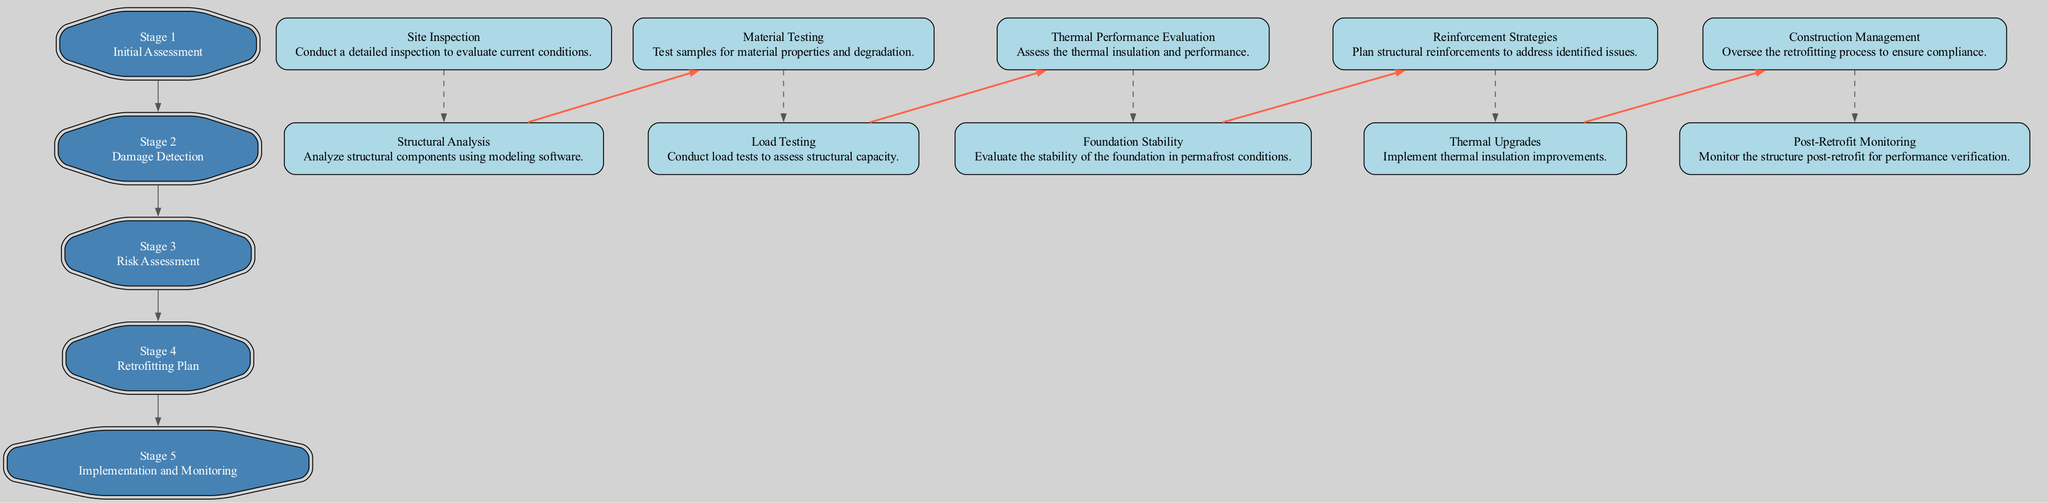What is the first stage in the clinical pathway? The first stage listed in the diagram is "Initial Assessment." By reviewing the stages from top to bottom, "Initial Assessment" is identified as the first stage.
Answer: Initial Assessment How many elements are in the "Risk Assessment" stage? In the "Risk Assessment" stage, there are two elements: "Thermal Performance Evaluation" and "Foundation Stability." Counting the elements in this stage confirms there are two.
Answer: 2 Which tools are used for "Material Testing"? The tools listed for "Material Testing" are: "Universal Testing Machine," "Spectrometer," and "Ultrasonic Tester." These three tools are specified under the "Material Testing" element in the "Damage Detection" stage.
Answer: Universal Testing Machine, Spectrometer, Ultrasonic Tester What is the last stage in the clinical pathway? The last stage is "Implementation and Monitoring," as it is the final stage when viewed in sequence from top to bottom. This is confirmed as the fifth stage.
Answer: Implementation and Monitoring Which stage includes "Reinforcement Strategies"? "Reinforcement Strategies" is included in the "Retrofitting Plan" stage. This can be identified by looking at the elements listed under this specific stage.
Answer: Retrofitting Plan How many stages are there in total? There are five stages total in the clinical pathway diagram. Counting each of the stages listed results in this total.
Answer: 5 What are the two elements in the "Damage Detection" stage? The two elements in the "Damage Detection" stage are "Material Testing" and "Load Testing." Reviewing that specific stage provides the names of both elements.
Answer: Material Testing, Load Testing What type of evaluation is conducted in the "Risk Assessment" stage? The evaluation conducted in the "Risk Assessment" stage is both "Thermal Performance Evaluation" and "Foundation Stability" which can be seen in the elements listed in that stage.
Answer: Thermal Performance Evaluation, Foundation Stability Which tools are listed for "Post-Retrofit Monitoring"? The tools listed for "Post-Retrofit Monitoring" include "Continuous Monitoring Systems," "Remote Sensors," and "Data Loggers." By looking at the corresponding element, these tools are clearly identified.
Answer: Continuous Monitoring Systems, Remote Sensors, Data Loggers 